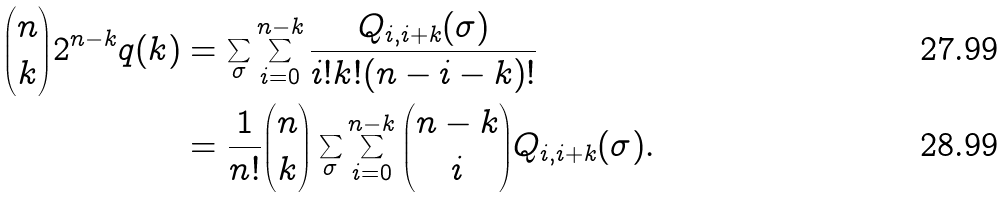Convert formula to latex. <formula><loc_0><loc_0><loc_500><loc_500>{ n \choose k } 2 ^ { n - k } q ( k ) & = \sum _ { \sigma } \sum _ { i = 0 } ^ { n - k } \frac { Q _ { i , i + k } ( \sigma ) } { i ! k ! ( n - i - k ) ! } \\ & = \frac { 1 } { n ! } { n \choose k } \sum _ { \sigma } \sum _ { i = 0 } ^ { n - k } { n - k \choose i } Q _ { i , i + k } ( \sigma ) .</formula> 